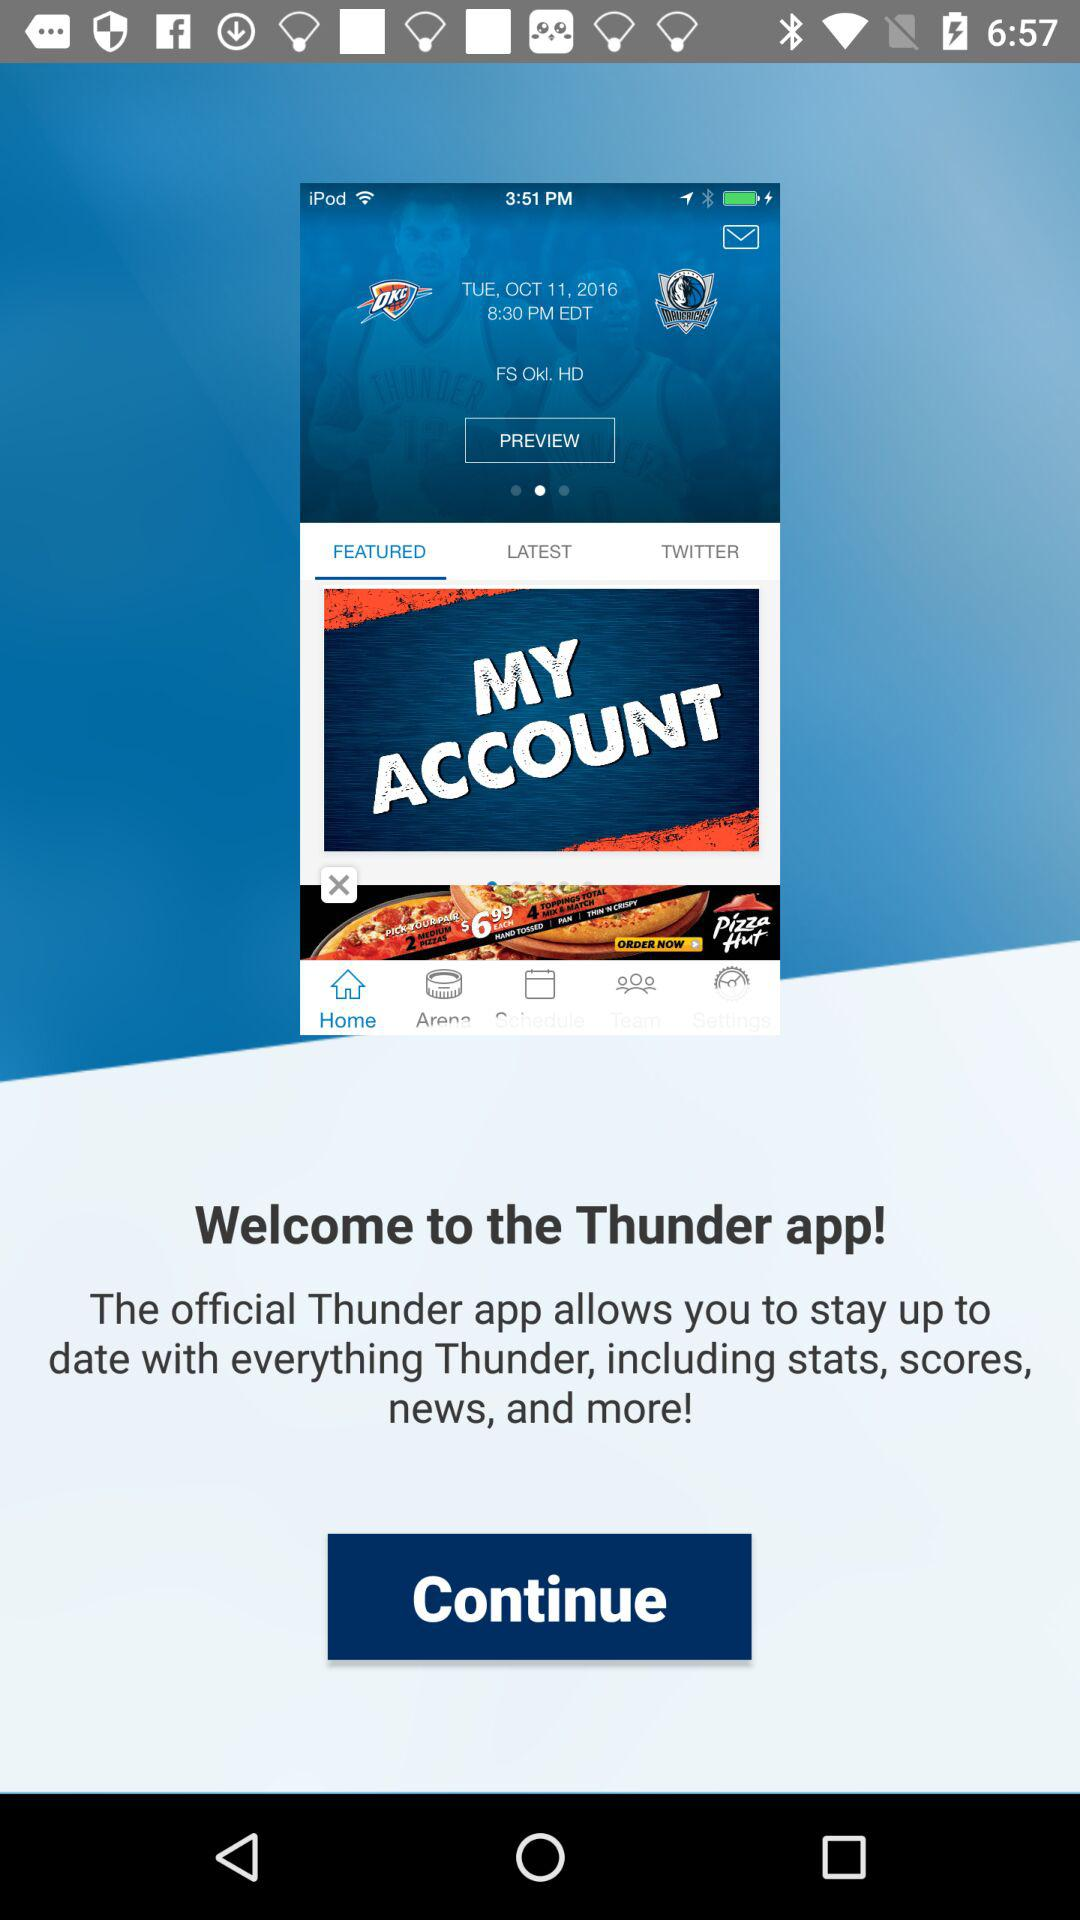What kind of information is provided by the application to stay up-to-date? The information includes stats, scores, news, and more!. 